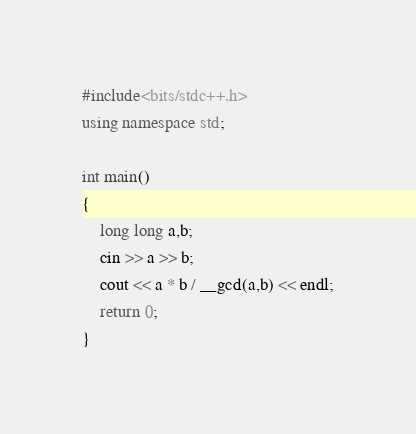<code> <loc_0><loc_0><loc_500><loc_500><_C++_>#include<bits/stdc++.h>
using namespace std;

int main()
{
  	long long a,b;
  	cin >> a >> b;
  	cout << a * b / __gcd(a,b) << endl;
	return 0;
}
</code> 